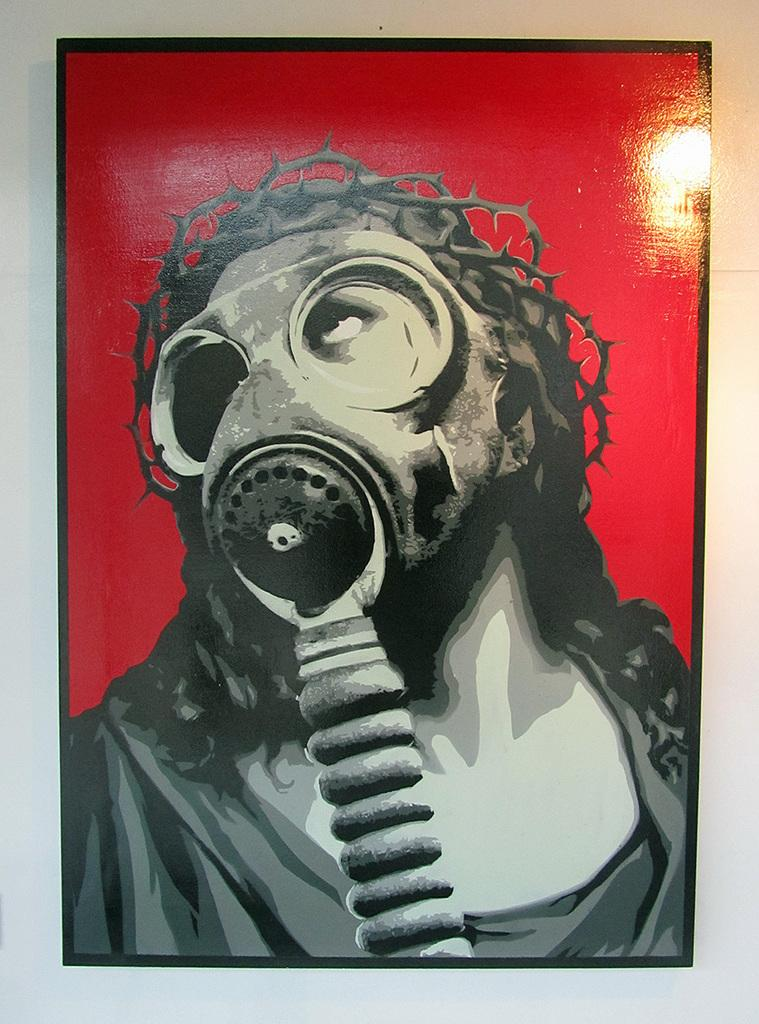What is hanging on the wall in the image? There is a painting on the wall in the image. What type of wool is being used by the team in the image? There is no team or wool present in the image; it only features a painting on the wall. 